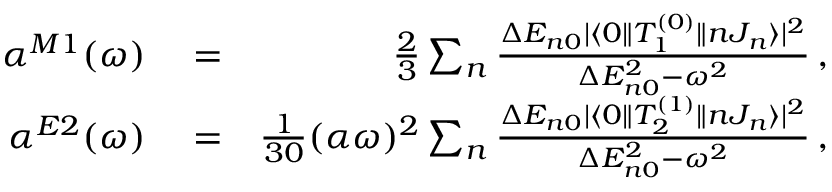Convert formula to latex. <formula><loc_0><loc_0><loc_500><loc_500>\begin{array} { r l r } { \alpha ^ { M 1 } ( \omega ) } & = } & { \frac { 2 } { 3 } \sum _ { n } \frac { \Delta E _ { n 0 } | \langle 0 \| T _ { 1 } ^ { ( 0 ) } \| n J _ { n } \rangle | ^ { 2 } } { \Delta E _ { n 0 } ^ { 2 } - \omega ^ { 2 } } \, , } \\ { \alpha ^ { E 2 } ( \omega ) } & = } & { \frac { 1 } { 3 0 } ( \alpha \omega ) ^ { 2 } \sum _ { n } \frac { \Delta E _ { n 0 } | \langle 0 \| T _ { 2 } ^ { ( 1 ) } \| n J _ { n } \rangle | ^ { 2 } } { \Delta E _ { n 0 } ^ { 2 } - \omega ^ { 2 } } \, , } \end{array}</formula> 